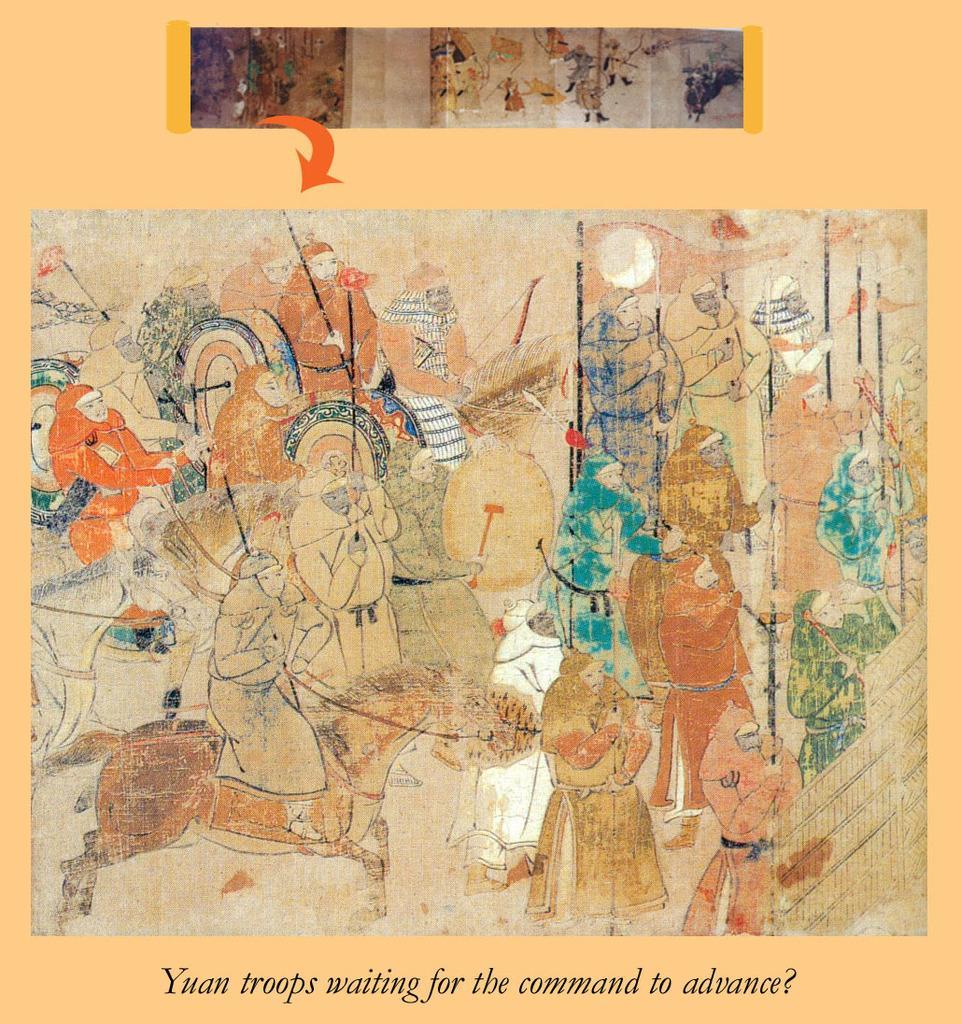Could you give a brief overview of what you see in this image? In this picture we can see painted board, on which we can see some text. 